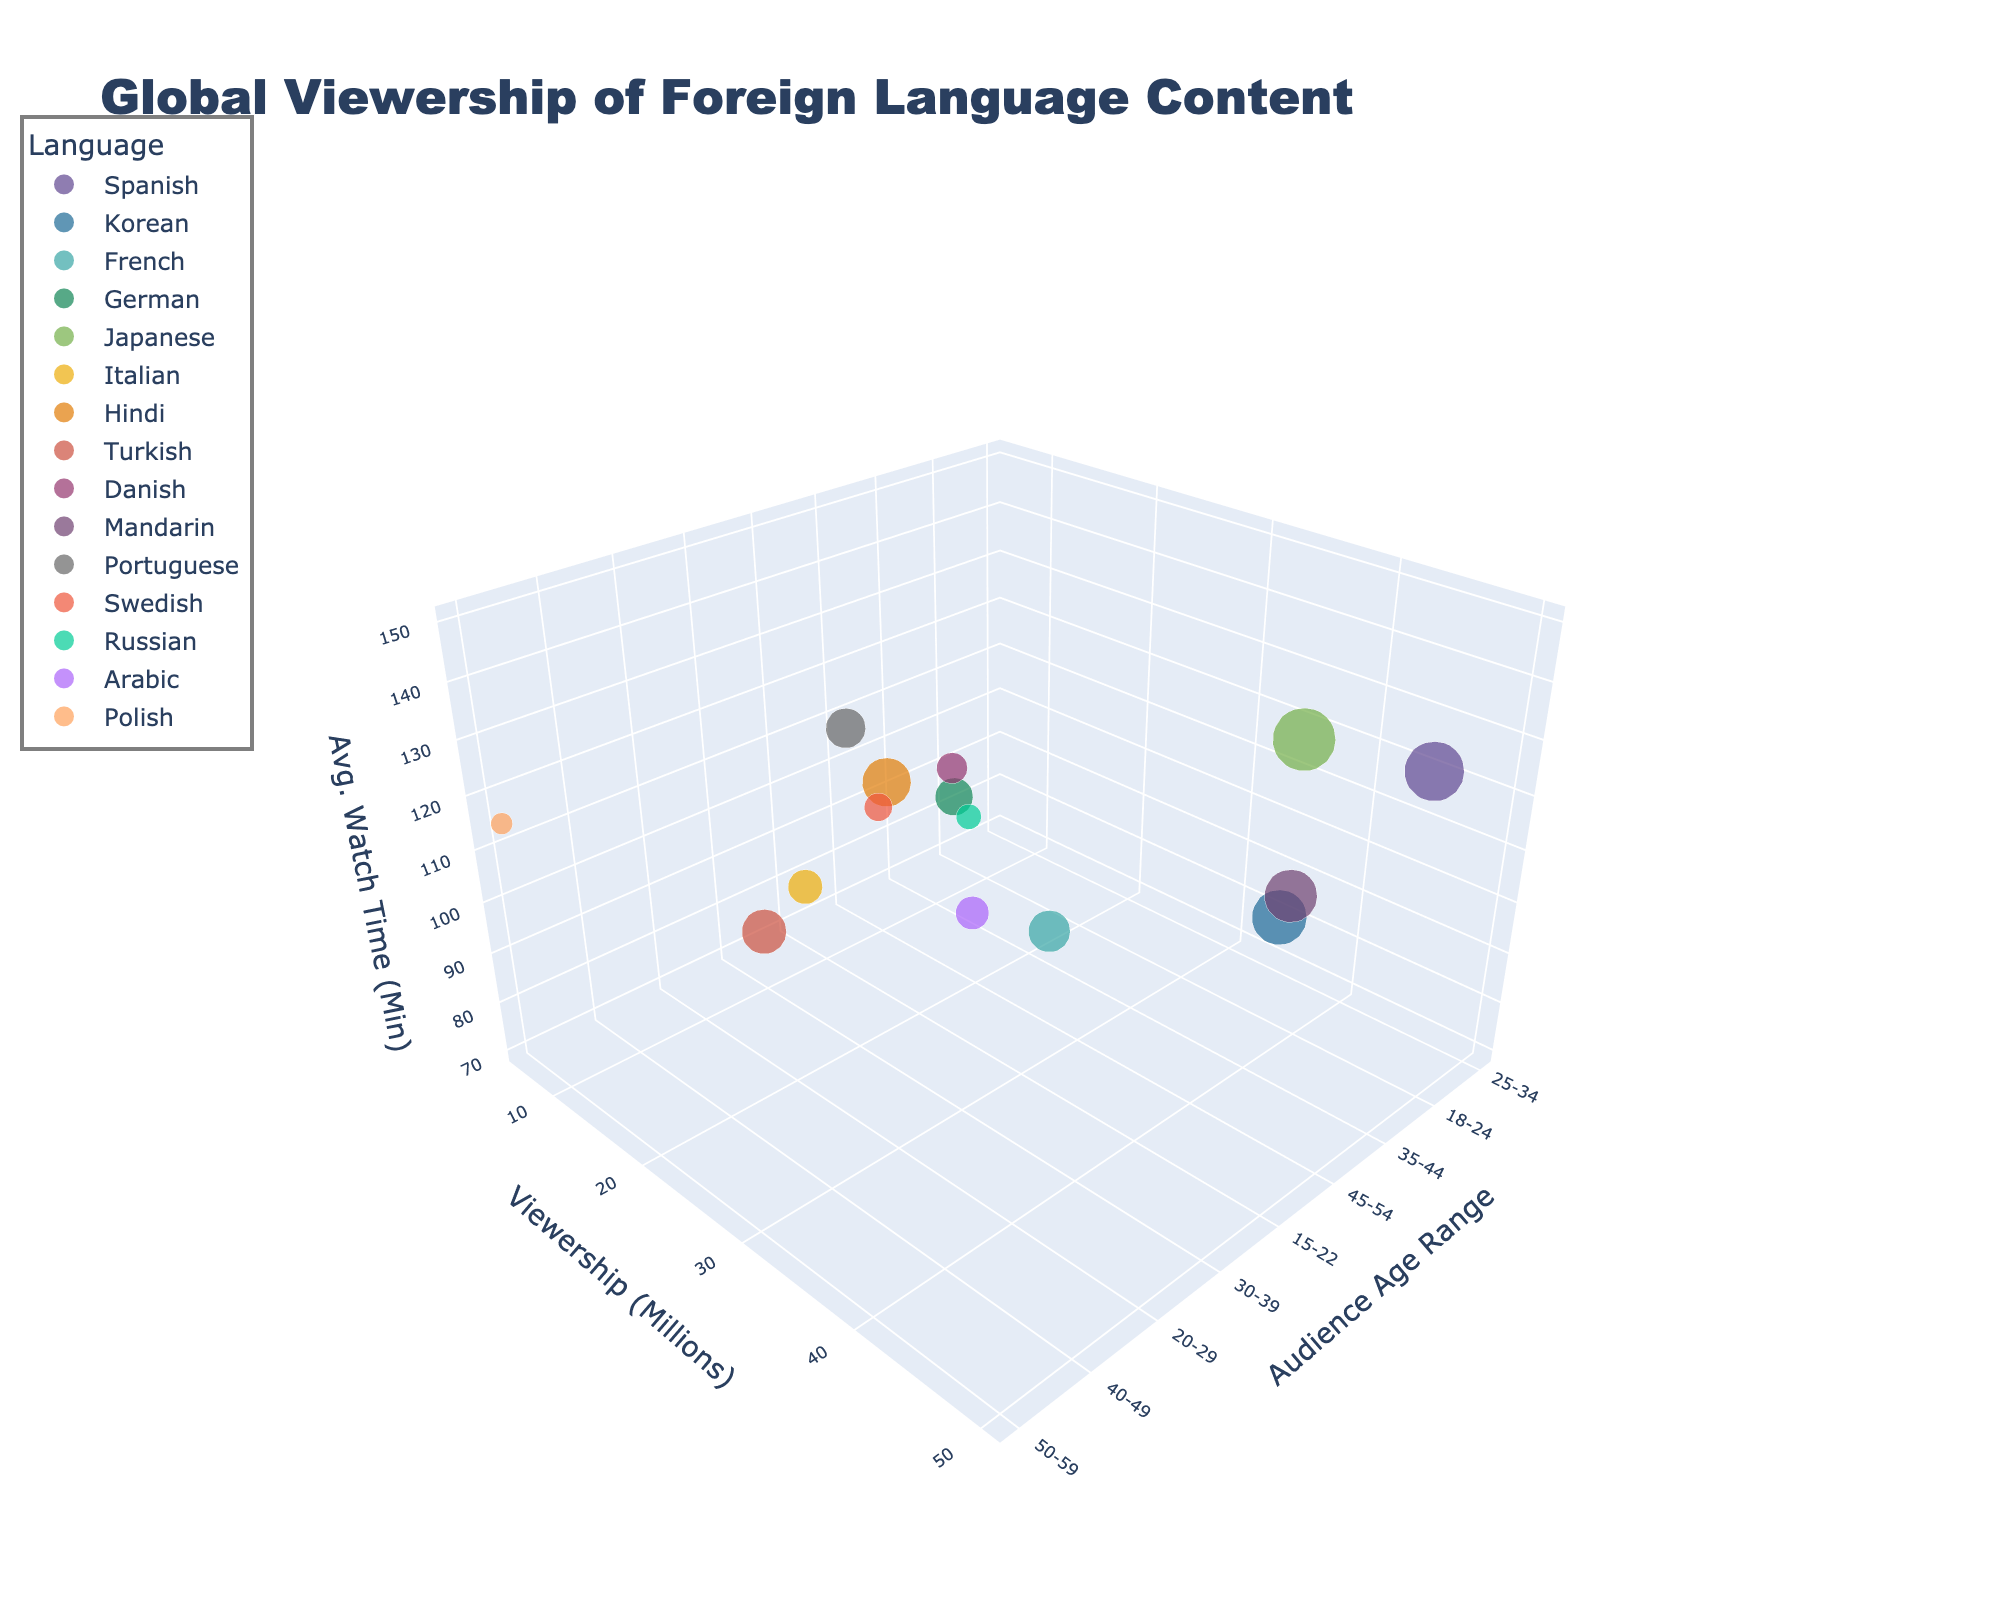What is the title of the figure? The title is located at the top of the figure. It reads, "Global Viewership of Foreign Language Content".
Answer: Global Viewership of Foreign Language Content How many data points represent non-European languages? To find this, identify the languages from non-European regions and count the corresponding bubbles. Non-European languages here are Spanish, Korean, Japanese, Hindi, Mandarin, Turkish, Arabic. This covers 7 languages.
Answer: 7 Which language has the highest viewership among the 25-34 age group? Look for the bubbles corresponding to the 25-34 age range and compare their sizes. The largest one in this range corresponds to Spanish with 45 million viewers.
Answer: Spanish Which genre has the lowest average watch time, and what is its audience age range? Examine all bubbles to find the one with the smallest Z-axis value (Avg. Watch Time). The bubble with the lowest average watch time is for French with a Comedy genre and an audience age of 35-44.
Answer: Comedy, 35-44 age range If you sum the viewership of the Romance and Thriller genres, what is the total? Locate the bubbles for Romance (Korean: 38 million) and Thriller (German: 18 million) genres and sum their viewership. 38 + 18 = 56 million viewers.
Answer: 56 million Which audience age group watches the most anime? Check the bubble for Japanese Anime and note its X-axis value for audience age, which is 15-22.
Answer: 15-22 Compare the average watch time of Nordic Noir and Telenovela genres. Which one has higher watch time and by how much? Look at the Z-axis for Danish Nordic Noir (100 minutes) and Portuguese Telenovela (130 minutes). The Telenovela has higher watch time. 130 - 100 = 30 minutes more.
Answer: Telenovela by 30 minutes Which language has the least representation based on viewership, and what genre does it represent? Identify the bubble with the smallest Y-axis value for viewership. Russian has the least representation with 8 million viewers and it is of the Sci-Fi genre.
Answer: Russian, Sci-Fi What is the range of audience ages for Hindi content viewers? Find the bubble for Hindi Bollywood and check its value on the X-axis, which is 20-29.
Answer: 20-29 